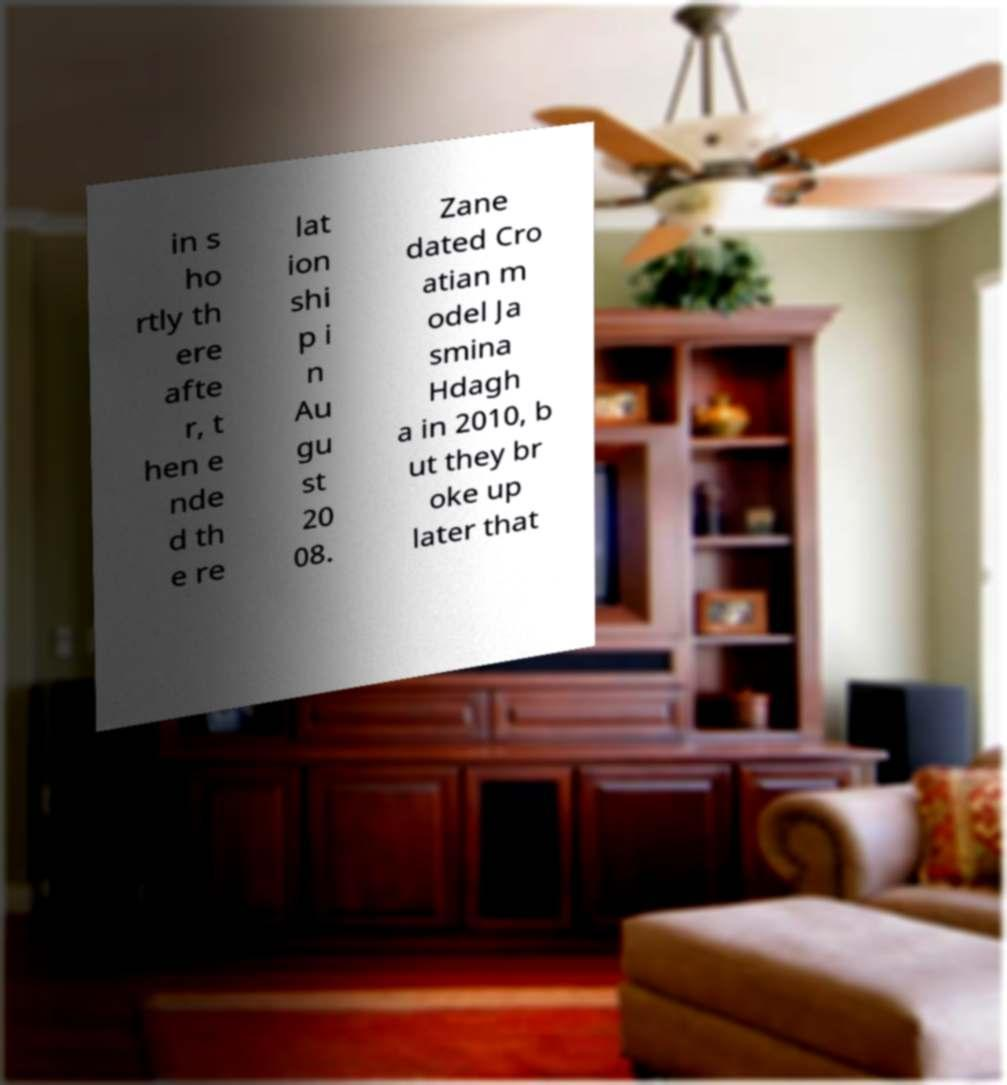Can you accurately transcribe the text from the provided image for me? in s ho rtly th ere afte r, t hen e nde d th e re lat ion shi p i n Au gu st 20 08. Zane dated Cro atian m odel Ja smina Hdagh a in 2010, b ut they br oke up later that 